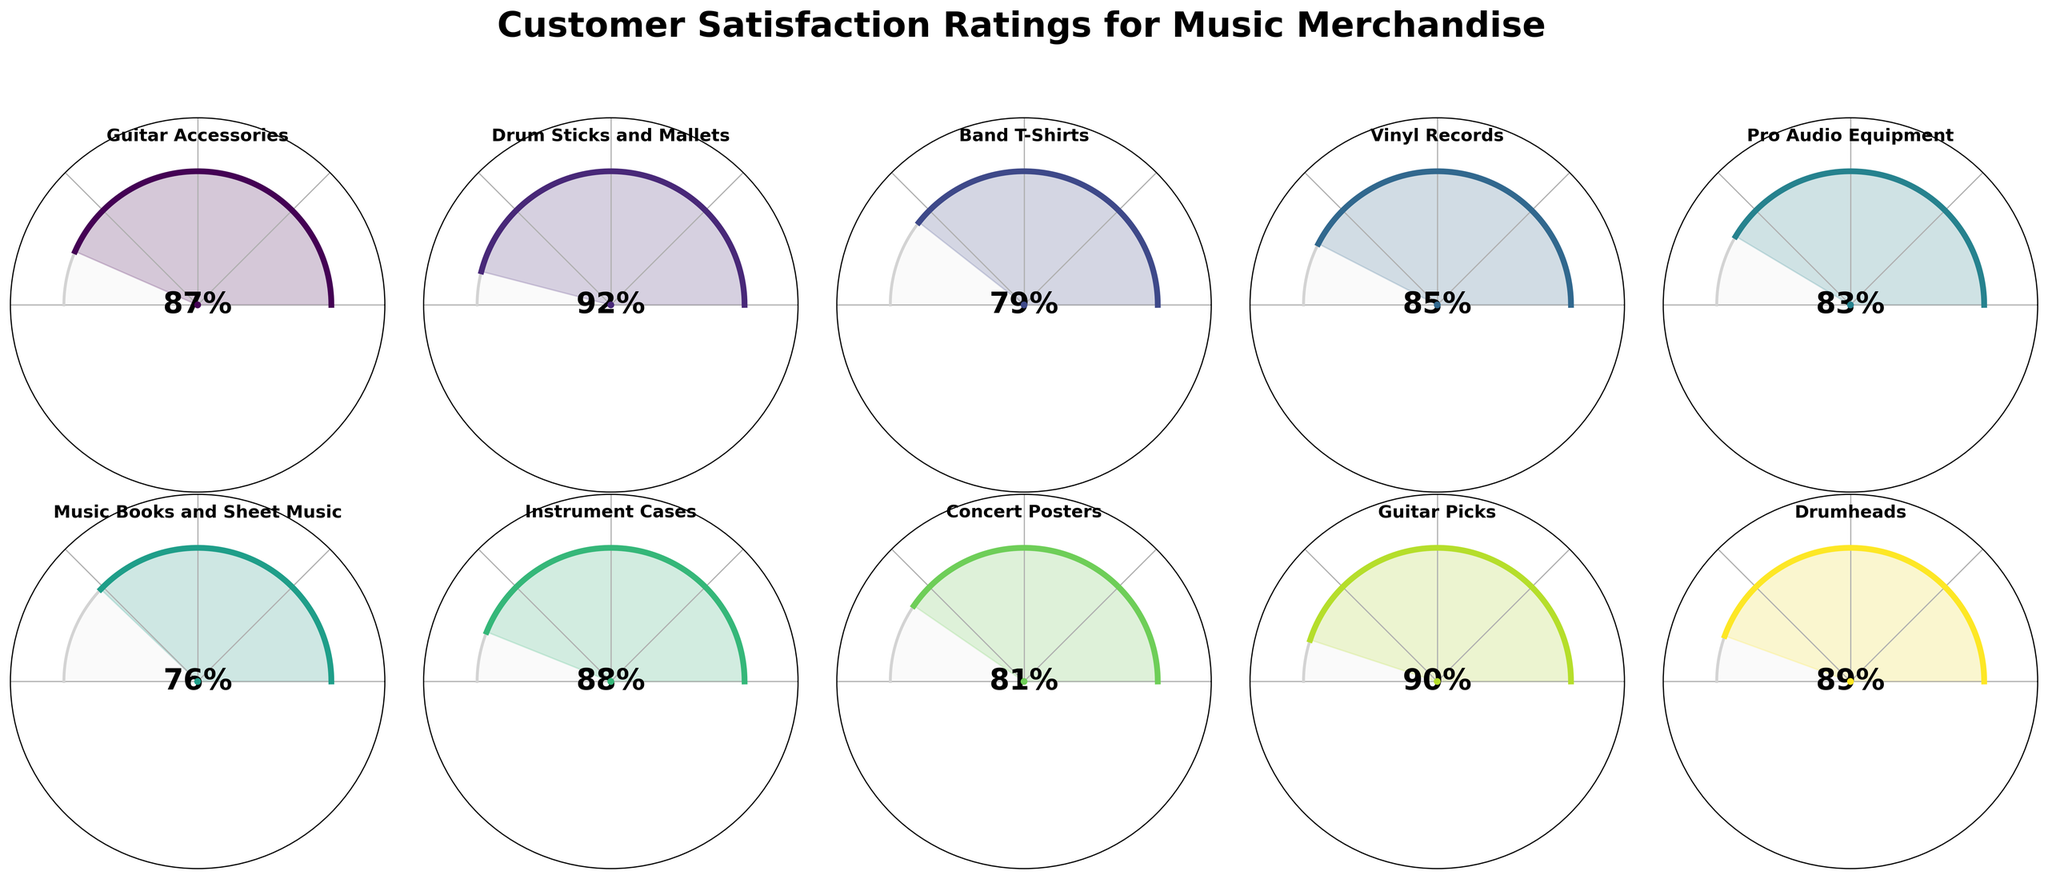What is the satisfaction rating for Drum Sticks and Mallets? The plot shows that the satisfaction rating for Drum Sticks and Mallets is 92%, as indicated at the center of the gauge chart for this category.
Answer: 92% Which music merchandise category has the lowest customer satisfaction rating? By comparing all the ratings on the gauge charts, Music Books and Sheet Music have the lowest customer satisfaction rating at 76%.
Answer: Music Books and Sheet Music What is the average satisfaction rating across all music merchandise categories? To find the average, sum up all the satisfaction ratings and divide by the number of categories: (87+92+79+85+83+76+88+81+90+89)/10 = 850/10 = 85.
Answer: 85 How many categories have a satisfaction rating above 85%? Count the number of categories with a rating higher than 85%: Guitar Accessories (87), Drum Sticks and Mallets (92), Instrument Cases (88), Guitar Picks (90), Drumheads (89). There are 5 categories.
Answer: 5 Which category has a satisfaction rating closest to the average rating of 85%? Compare each rating to the average (85): Vinyl Records (85) is exactly 85, and then the closest would be Pro Audio Equipment (83).
Answer: Vinyl Records Are there more categories with satisfaction ratings above 80% or below 80%? Count the number of categories above and below 80%: Above 80% (7 categories: Guitar Accessories, Drum Sticks and Mallets, Vinyl Records, Pro Audio Equipment, Instrument Cases, Guitar Picks, Drumheads), Below 80% (3 categories: Band T-Shirts, Music Books and Sheet Music, Concert Posters). There are more categories above 80%.
Answer: Above 80% How does the satisfaction rating for Band T-Shirts compare to Concert Posters? The satisfaction rating for Band T-Shirts is 79%, while for Concert Posters it is 81%. Therefore, Concert Posters have a higher rating by 2%.
Answer: Concert Posters are higher Which categories have ratings between 80% and 90%? Identify the categories within the 80-90% range: Guitar Accessories (87), Vinyl Records (85), Pro Audio Equipment (83), Instrument Cases (88), Concert Posters (81), Drumheads (89).
Answer: Guitar Accessories, Vinyl Records, Pro Audio Equipment, Instrument Cases, Concert Posters, Drumheads What is the difference in satisfaction rating between the highest and lowest rated categories? The highest satisfaction rating is 92% (Drum Sticks and Mallets), and the lowest is 76% (Music Books and Sheet Music). The difference is 92% - 76% = 16%.
Answer: 16% 